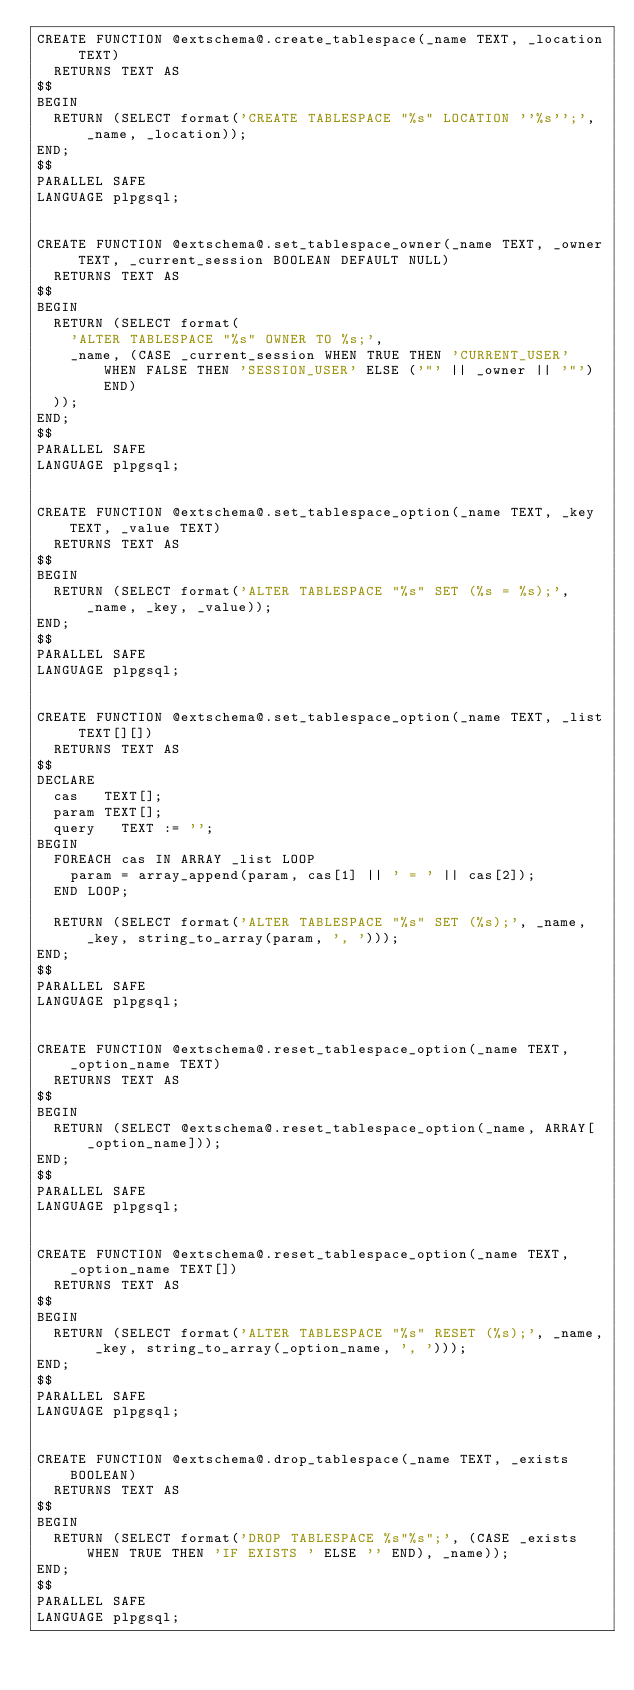<code> <loc_0><loc_0><loc_500><loc_500><_SQL_>CREATE FUNCTION @extschema@.create_tablespace(_name TEXT, _location TEXT)
  RETURNS TEXT AS
$$
BEGIN
	RETURN (SELECT format('CREATE TABLESPACE "%s" LOCATION ''%s'';', _name, _location));
END;
$$
PARALLEL SAFE
LANGUAGE plpgsql;


CREATE FUNCTION @extschema@.set_tablespace_owner(_name TEXT, _owner TEXT, _current_session BOOLEAN DEFAULT NULL)
  RETURNS TEXT AS
$$
BEGIN
	RETURN (SELECT format(
		'ALTER TABLESPACE "%s" OWNER TO %s;',
		_name, (CASE _current_session WHEN TRUE THEN 'CURRENT_USER' WHEN FALSE THEN 'SESSION_USER' ELSE ('"' || _owner || '"') END)
	));
END;
$$
PARALLEL SAFE
LANGUAGE plpgsql;


CREATE FUNCTION @extschema@.set_tablespace_option(_name TEXT, _key TEXT, _value TEXT)
  RETURNS TEXT AS
$$
BEGIN
	RETURN (SELECT format('ALTER TABLESPACE "%s" SET (%s = %s);', _name, _key, _value));
END;
$$
PARALLEL SAFE
LANGUAGE plpgsql;


CREATE FUNCTION @extschema@.set_tablespace_option(_name TEXT, _list TEXT[][])
  RETURNS TEXT AS
$$
DECLARE
	cas 	TEXT[];
	param	TEXT[];
	query 	TEXT := '';
BEGIN
	FOREACH cas IN ARRAY _list LOOP
	  param = array_append(param, cas[1] || ' = ' || cas[2]);
	END LOOP;

	RETURN (SELECT format('ALTER TABLESPACE "%s" SET (%s);', _name, _key, string_to_array(param, ', ')));
END;
$$
PARALLEL SAFE
LANGUAGE plpgsql;


CREATE FUNCTION @extschema@.reset_tablespace_option(_name TEXT, _option_name TEXT)
  RETURNS TEXT AS
$$
BEGIN
	RETURN (SELECT @extschema@.reset_tablespace_option(_name, ARRAY[_option_name]));
END;
$$
PARALLEL SAFE
LANGUAGE plpgsql;


CREATE FUNCTION @extschema@.reset_tablespace_option(_name TEXT, _option_name TEXT[])
  RETURNS TEXT AS
$$
BEGIN
	RETURN (SELECT format('ALTER TABLESPACE "%s" RESET (%s);', _name, _key, string_to_array(_option_name, ', ')));
END;
$$
PARALLEL SAFE
LANGUAGE plpgsql;


CREATE FUNCTION @extschema@.drop_tablespace(_name TEXT, _exists BOOLEAN)
  RETURNS TEXT AS
$$
BEGIN
	RETURN (SELECT format('DROP TABLESPACE %s"%s";', (CASE _exists WHEN TRUE THEN 'IF EXISTS ' ELSE '' END), _name));
END;
$$
PARALLEL SAFE
LANGUAGE plpgsql;
</code> 